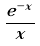Convert formula to latex. <formula><loc_0><loc_0><loc_500><loc_500>\frac { e ^ { - x } } { x }</formula> 